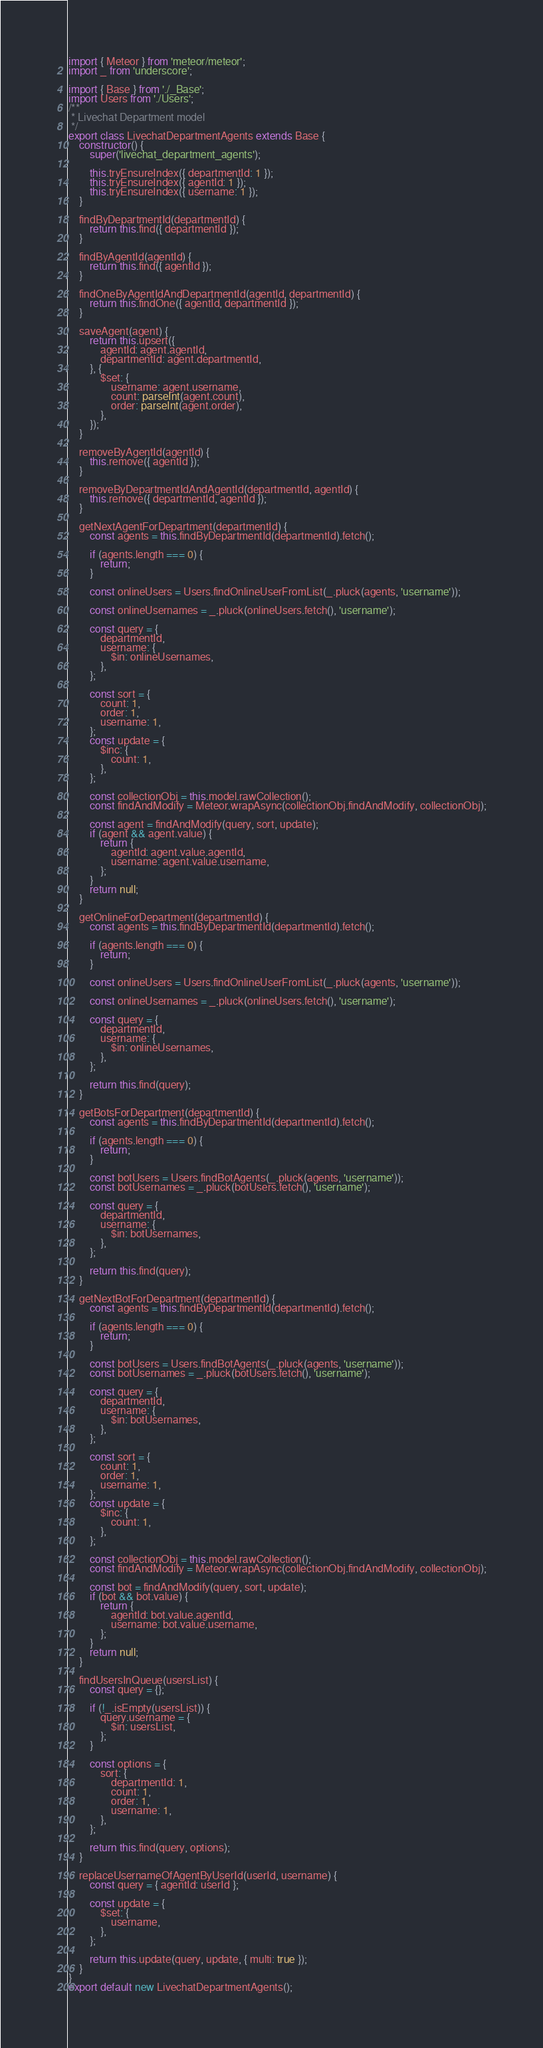Convert code to text. <code><loc_0><loc_0><loc_500><loc_500><_JavaScript_>import { Meteor } from 'meteor/meteor';
import _ from 'underscore';

import { Base } from './_Base';
import Users from './Users';
/**
 * Livechat Department model
 */
export class LivechatDepartmentAgents extends Base {
	constructor() {
		super('livechat_department_agents');

		this.tryEnsureIndex({ departmentId: 1 });
		this.tryEnsureIndex({ agentId: 1 });
		this.tryEnsureIndex({ username: 1 });
	}

	findByDepartmentId(departmentId) {
		return this.find({ departmentId });
	}

	findByAgentId(agentId) {
		return this.find({ agentId });
	}

	findOneByAgentIdAndDepartmentId(agentId, departmentId) {
		return this.findOne({ agentId, departmentId });
	}

	saveAgent(agent) {
		return this.upsert({
			agentId: agent.agentId,
			departmentId: agent.departmentId,
		}, {
			$set: {
				username: agent.username,
				count: parseInt(agent.count),
				order: parseInt(agent.order),
			},
		});
	}

	removeByAgentId(agentId) {
		this.remove({ agentId });
	}

	removeByDepartmentIdAndAgentId(departmentId, agentId) {
		this.remove({ departmentId, agentId });
	}

	getNextAgentForDepartment(departmentId) {
		const agents = this.findByDepartmentId(departmentId).fetch();

		if (agents.length === 0) {
			return;
		}

		const onlineUsers = Users.findOnlineUserFromList(_.pluck(agents, 'username'));

		const onlineUsernames = _.pluck(onlineUsers.fetch(), 'username');

		const query = {
			departmentId,
			username: {
				$in: onlineUsernames,
			},
		};

		const sort = {
			count: 1,
			order: 1,
			username: 1,
		};
		const update = {
			$inc: {
				count: 1,
			},
		};

		const collectionObj = this.model.rawCollection();
		const findAndModify = Meteor.wrapAsync(collectionObj.findAndModify, collectionObj);

		const agent = findAndModify(query, sort, update);
		if (agent && agent.value) {
			return {
				agentId: agent.value.agentId,
				username: agent.value.username,
			};
		}
		return null;
	}

	getOnlineForDepartment(departmentId) {
		const agents = this.findByDepartmentId(departmentId).fetch();

		if (agents.length === 0) {
			return;
		}

		const onlineUsers = Users.findOnlineUserFromList(_.pluck(agents, 'username'));

		const onlineUsernames = _.pluck(onlineUsers.fetch(), 'username');

		const query = {
			departmentId,
			username: {
				$in: onlineUsernames,
			},
		};

		return this.find(query);
	}

	getBotsForDepartment(departmentId) {
		const agents = this.findByDepartmentId(departmentId).fetch();

		if (agents.length === 0) {
			return;
		}

		const botUsers = Users.findBotAgents(_.pluck(agents, 'username'));
		const botUsernames = _.pluck(botUsers.fetch(), 'username');

		const query = {
			departmentId,
			username: {
				$in: botUsernames,
			},
		};

		return this.find(query);
	}

	getNextBotForDepartment(departmentId) {
		const agents = this.findByDepartmentId(departmentId).fetch();

		if (agents.length === 0) {
			return;
		}

		const botUsers = Users.findBotAgents(_.pluck(agents, 'username'));
		const botUsernames = _.pluck(botUsers.fetch(), 'username');

		const query = {
			departmentId,
			username: {
				$in: botUsernames,
			},
		};

		const sort = {
			count: 1,
			order: 1,
			username: 1,
		};
		const update = {
			$inc: {
				count: 1,
			},
		};

		const collectionObj = this.model.rawCollection();
		const findAndModify = Meteor.wrapAsync(collectionObj.findAndModify, collectionObj);

		const bot = findAndModify(query, sort, update);
		if (bot && bot.value) {
			return {
				agentId: bot.value.agentId,
				username: bot.value.username,
			};
		}
		return null;
	}

	findUsersInQueue(usersList) {
		const query = {};

		if (!_.isEmpty(usersList)) {
			query.username = {
				$in: usersList,
			};
		}

		const options = {
			sort: {
				departmentId: 1,
				count: 1,
				order: 1,
				username: 1,
			},
		};

		return this.find(query, options);
	}

	replaceUsernameOfAgentByUserId(userId, username) {
		const query = { agentId: userId };

		const update = {
			$set: {
				username,
			},
		};

		return this.update(query, update, { multi: true });
	}
}
export default new LivechatDepartmentAgents();
</code> 